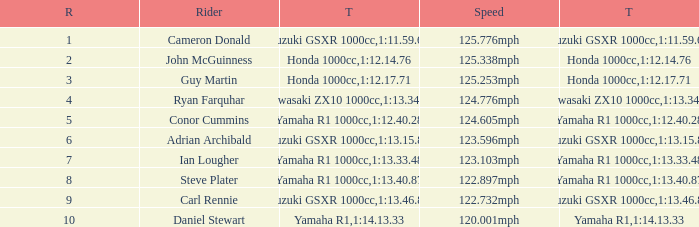What is the rank for the team with a Time of 1:12.40.28? 5.0. 